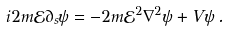<formula> <loc_0><loc_0><loc_500><loc_500>i 2 m { \mathcal { E } } \partial _ { s } \psi = - 2 m { \mathcal { E } } ^ { 2 } \nabla ^ { 2 } \psi + V \psi \, .</formula> 